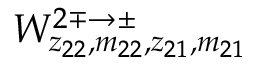<formula> <loc_0><loc_0><loc_500><loc_500>W _ { z _ { 2 2 } , m _ { 2 2 } , z _ { 2 1 } , m _ { 2 1 } } ^ { 2 \mp \rightarrow \pm }</formula> 